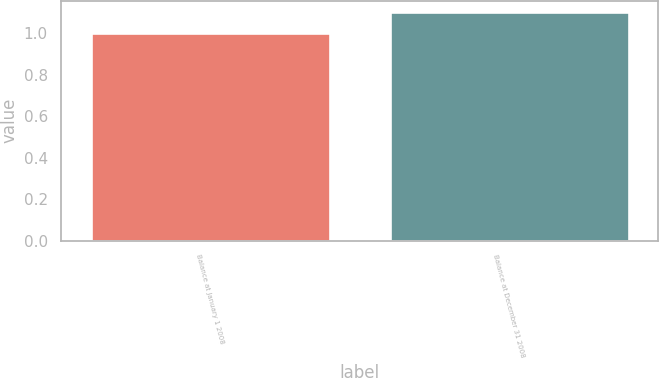Convert chart. <chart><loc_0><loc_0><loc_500><loc_500><bar_chart><fcel>Balance at January 1 2008<fcel>Balance at December 31 2008<nl><fcel>1<fcel>1.1<nl></chart> 